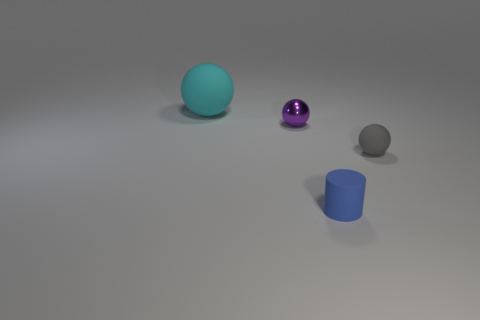Are there any purple balls that are behind the small thing that is behind the matte sphere right of the cyan rubber sphere? no 